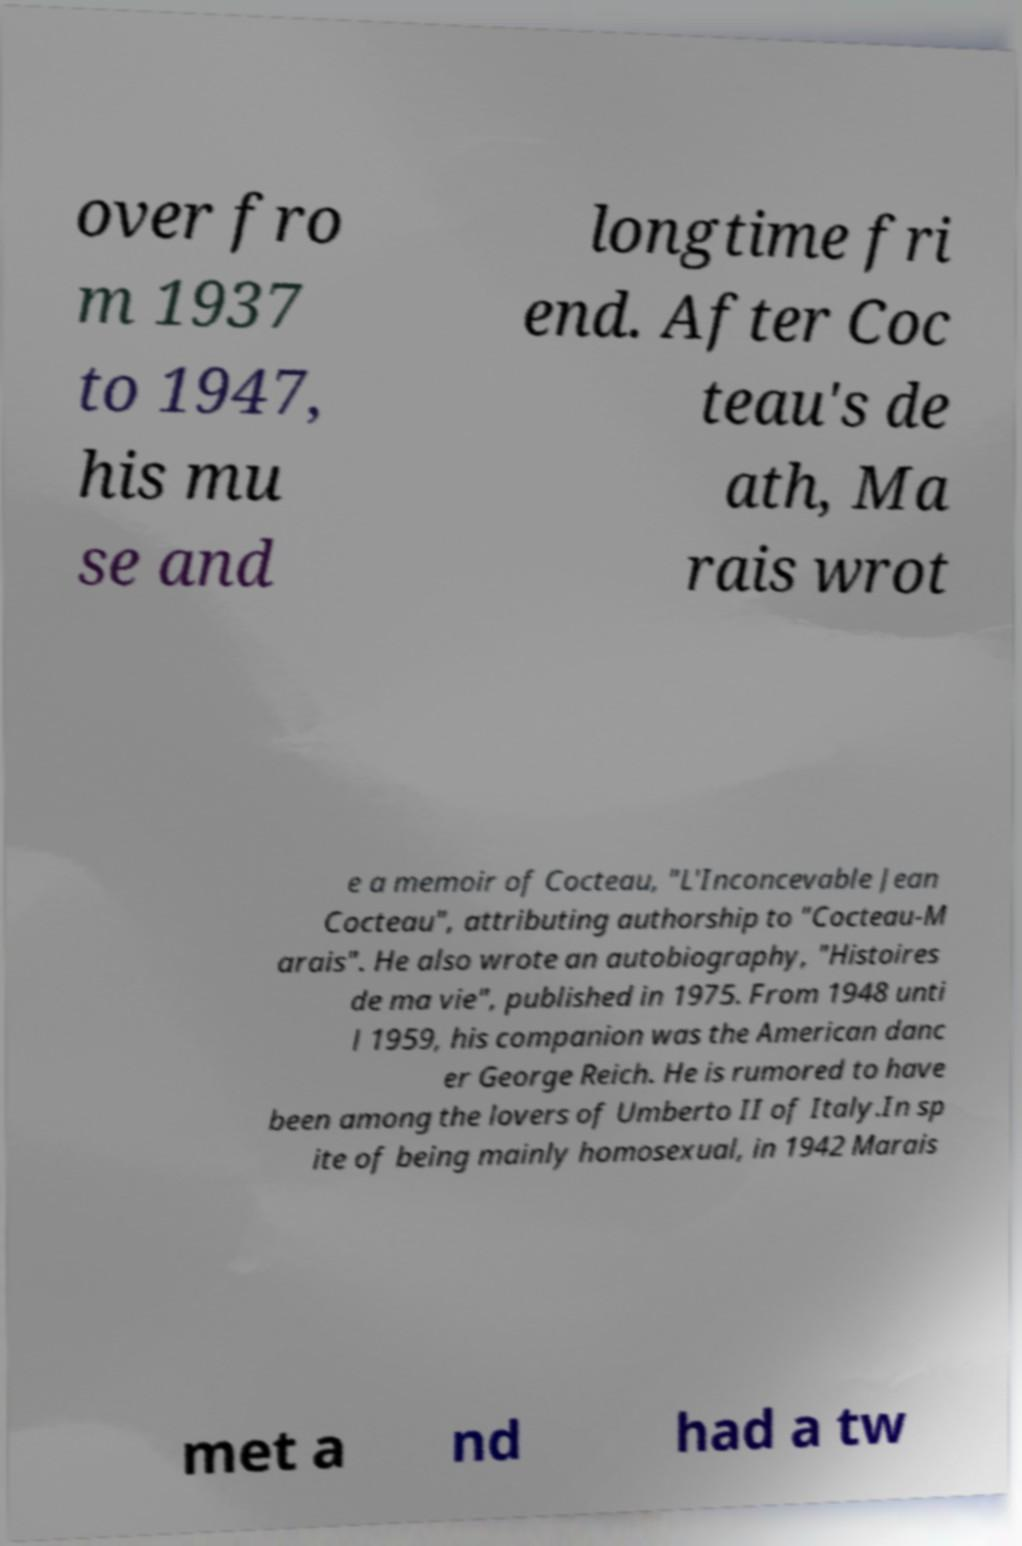What messages or text are displayed in this image? I need them in a readable, typed format. over fro m 1937 to 1947, his mu se and longtime fri end. After Coc teau's de ath, Ma rais wrot e a memoir of Cocteau, "L'Inconcevable Jean Cocteau", attributing authorship to "Cocteau-M arais". He also wrote an autobiography, "Histoires de ma vie", published in 1975. From 1948 unti l 1959, his companion was the American danc er George Reich. He is rumored to have been among the lovers of Umberto II of Italy.In sp ite of being mainly homosexual, in 1942 Marais met a nd had a tw 